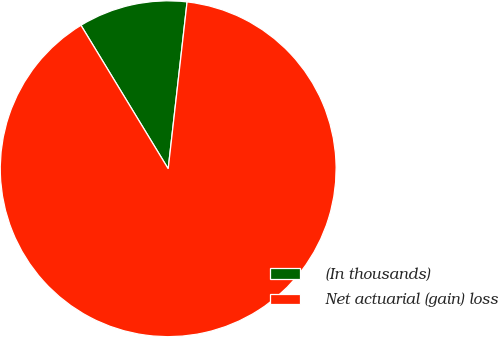Convert chart to OTSL. <chart><loc_0><loc_0><loc_500><loc_500><pie_chart><fcel>(In thousands)<fcel>Net actuarial (gain) loss<nl><fcel>10.49%<fcel>89.51%<nl></chart> 